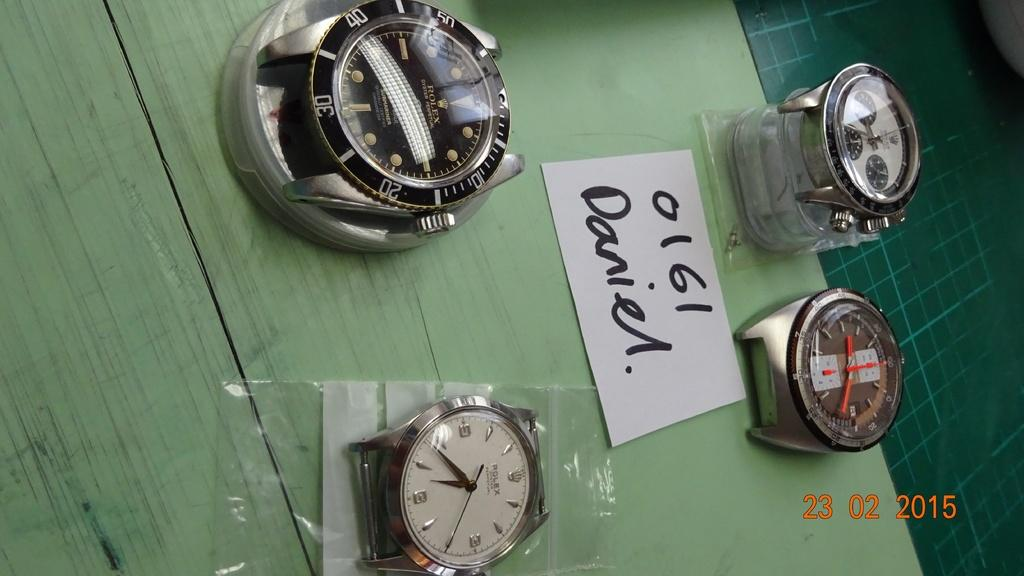Provide a one-sentence caption for the provided image. A photo of strapless watches from February 23 2015. 